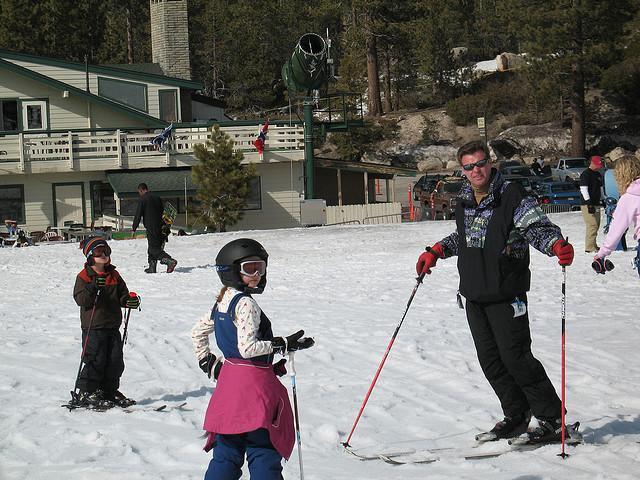How many people are wearing a pink hat?
Give a very brief answer. 0. How many girls are in this group?
Give a very brief answer. 2. How many people are visible?
Give a very brief answer. 4. 